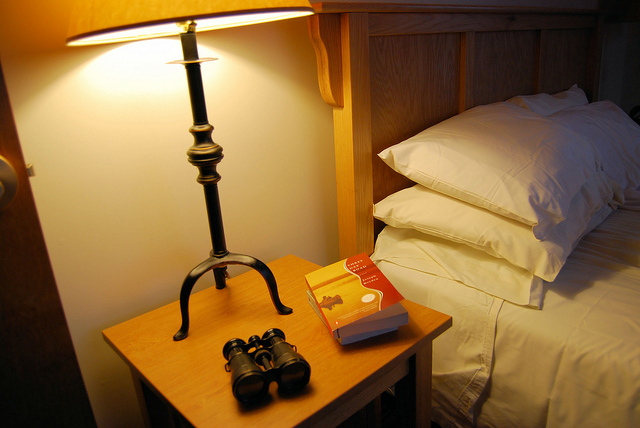What activity might someone be about to do or just finished doing based on the objects on the table? Given the presence of a book, a pair of binoculars, and the lamp being on, it suggests that someone might have been planning to read or just finished reading, possibly while observing the outdoors or wildlife earlier. 